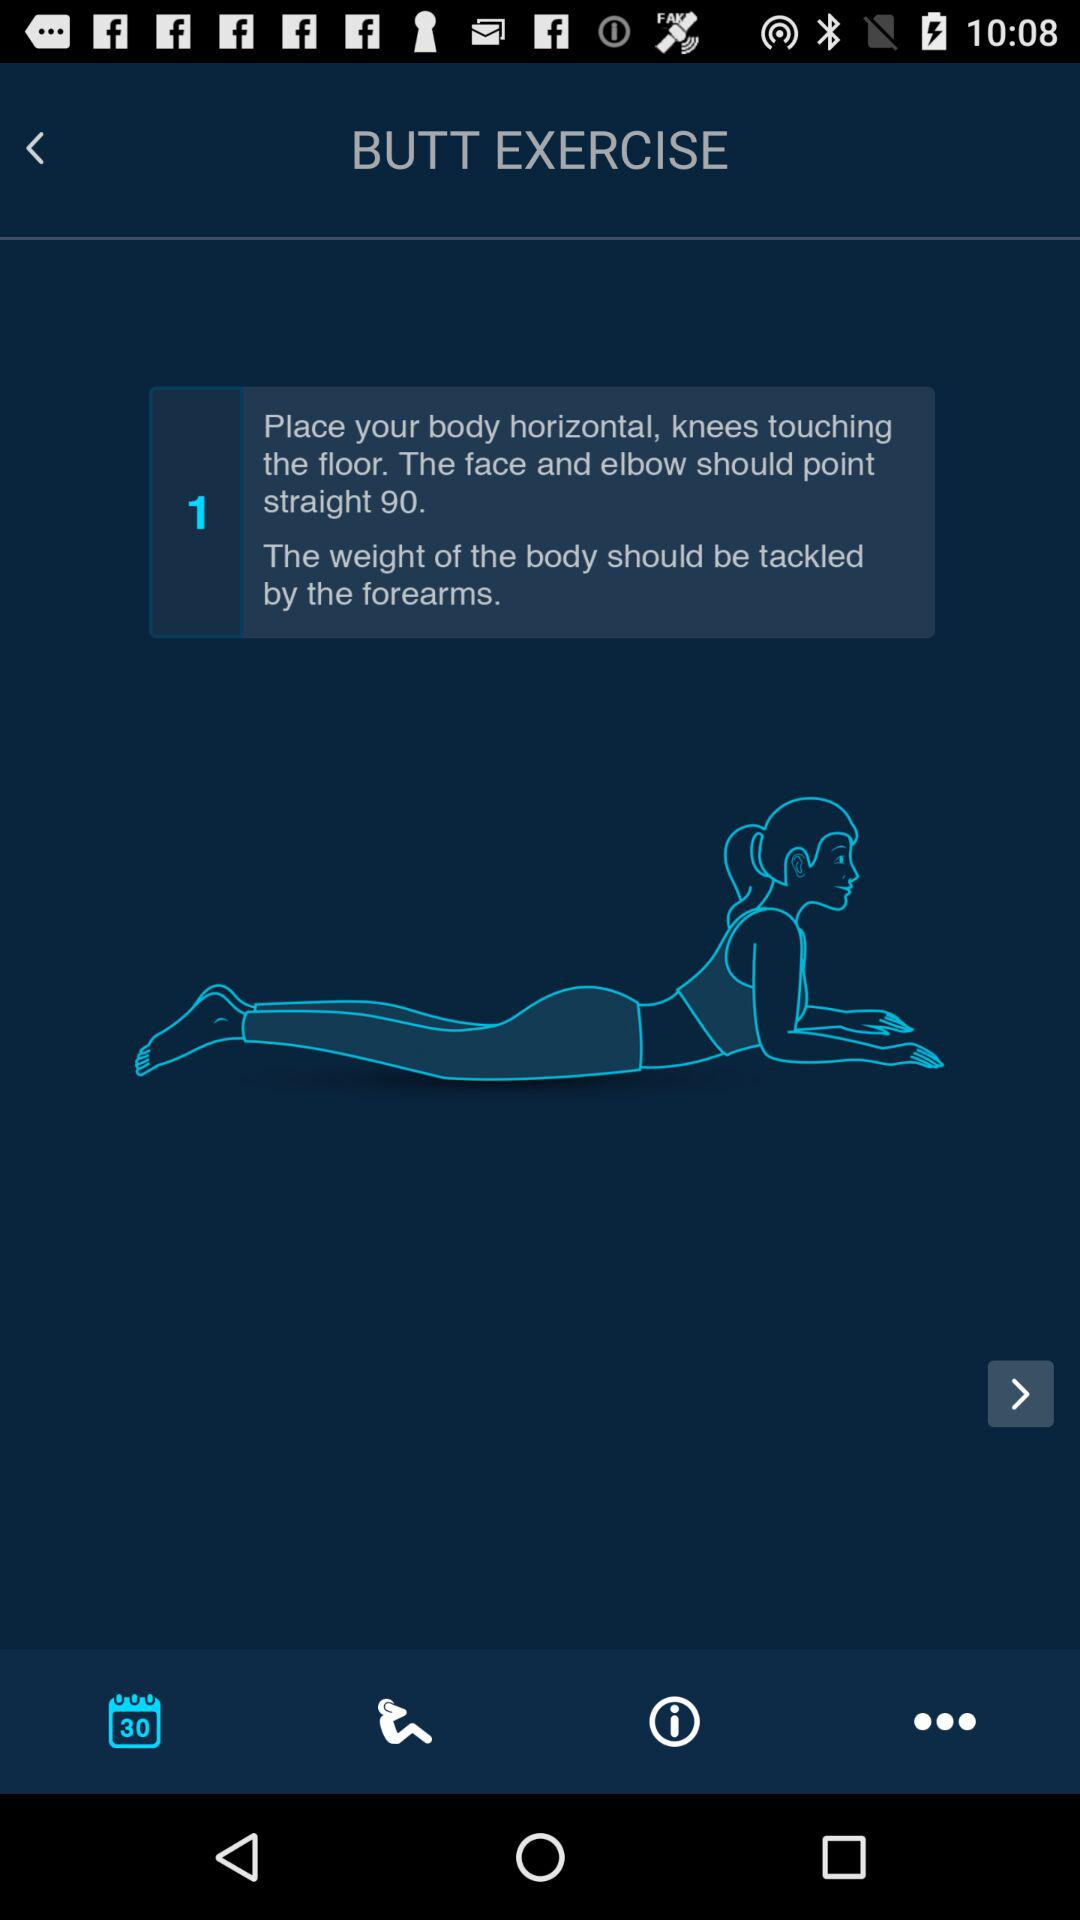What is the name of the exercise? The name of the exercise is butt. 